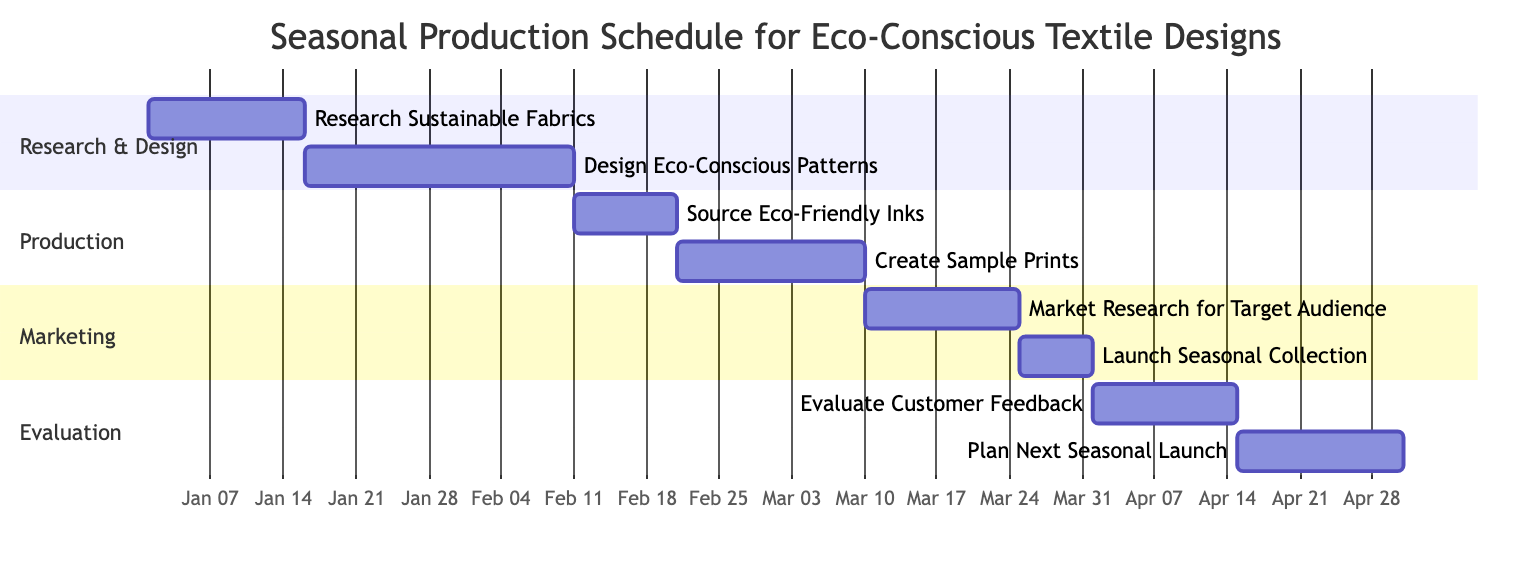What is the total number of tasks in the diagram? There are 8 distinct tasks listed in the Gantt chart for the seasonal production schedule. The tasks are: Research Sustainable Fabrics, Design Eco-Conscious Patterns, Source Eco-Friendly Inks, Create Sample Prints, Market Research for Target Audience, Launch Seasonal Collection, Evaluate Customer Feedback, and Plan Next Seasonal Launch.
Answer: 8 What is the end date of the "Design Eco-Conscious Patterns" task? The "Design Eco-Conscious Patterns" task starts on January 16, 2024, and ends on February 10, 2024. Therefore, the end date of this task is February 10.
Answer: February 10 What task follows the "Source Eco-Friendly Inks" task? The task that follows "Source Eco-Friendly Inks" is "Create Sample Prints." This can be confirmed by checking the flow of tasks where "Create Sample Prints" starts immediately after "Source Eco-Friendly Inks" ends.
Answer: Create Sample Prints How many days does the "Launch Seasonal Collection" task take? The "Launch Seasonal Collection" task begins on March 26, 2024, and ends on April 1, 2024. It spans a total of 7 days from start to finish.
Answer: 7 days What is the difference in start dates between "Create Sample Prints" and "Market Research for Target Audience"? "Create Sample Prints" starts on February 21, 2024, while "Market Research for Target Audience" starts on March 11, 2024. The difference in their start dates is 18 days, as February has 29 days in this leap year, leading to March 11 being 18 days after February 21.
Answer: 18 days What is the last task in the Gantt chart? The last task in the Gantt chart is "Plan Next Seasonal Launch," which follows the "Evaluate Customer Feedback" task and is indeed the final task in the sequence since it comes afterward.
Answer: Plan Next Seasonal Launch What is the duration of the entire production schedule? To determine the total duration of the production schedule, we look at the start date of the first task, "Research Sustainable Fabrics" on January 1, 2024, and the end date of the last task, "Plan Next Seasonal Launch" on May 1, 2024. This timeframe spans from January 1 to May 1, which is 120 days in total.
Answer: 120 days What section contains the task "Evaluate Customer Feedback"? The task "Evaluate Customer Feedback" is contained within the "Evaluation" section of the Gantt chart. This section clearly groups tasks related to assessing outcomes after the launch of the collection, including customer feedback.
Answer: Evaluation 